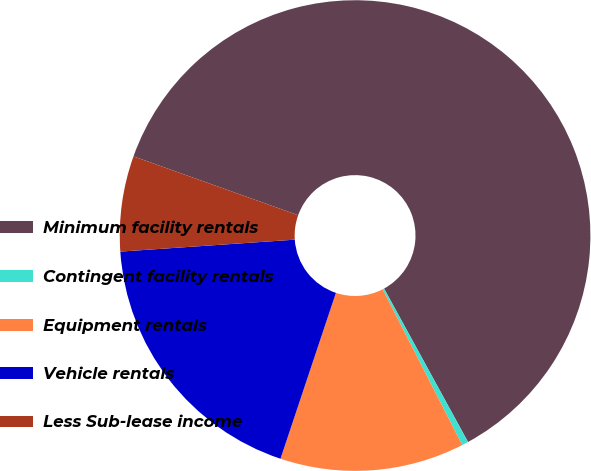Convert chart to OTSL. <chart><loc_0><loc_0><loc_500><loc_500><pie_chart><fcel>Minimum facility rentals<fcel>Contingent facility rentals<fcel>Equipment rentals<fcel>Vehicle rentals<fcel>Less Sub-lease income<nl><fcel>61.57%<fcel>0.44%<fcel>12.66%<fcel>18.78%<fcel>6.55%<nl></chart> 